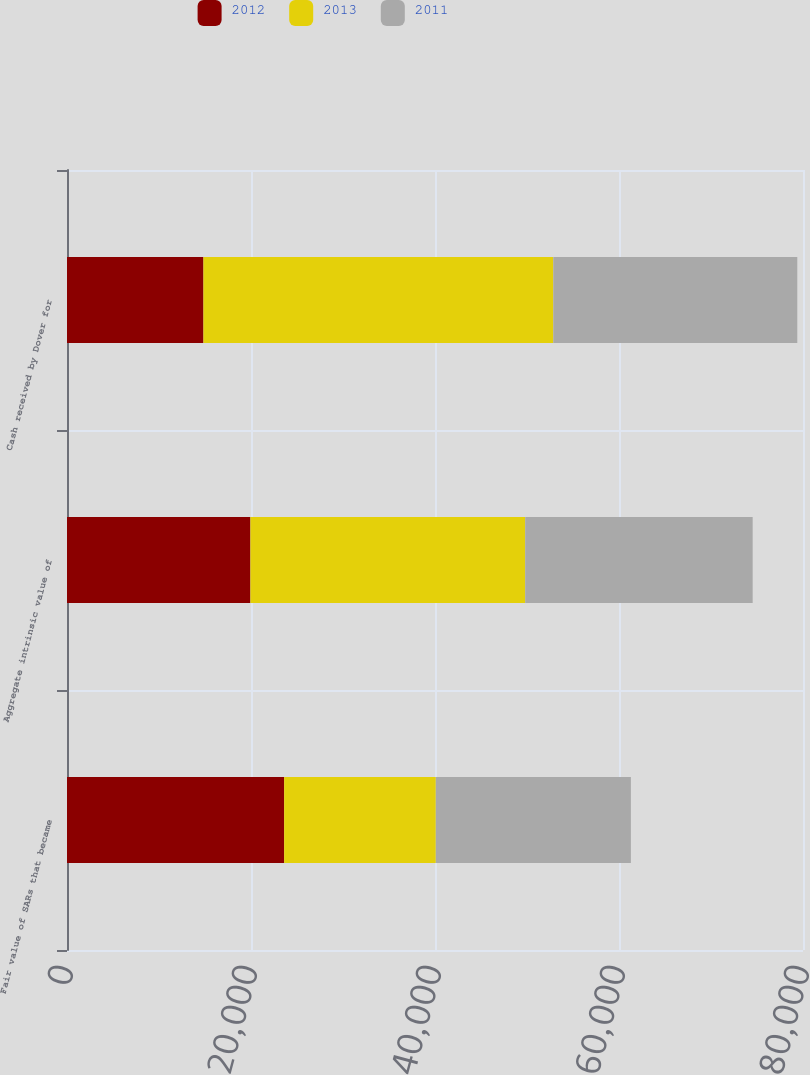Convert chart to OTSL. <chart><loc_0><loc_0><loc_500><loc_500><stacked_bar_chart><ecel><fcel>Fair value of SARs that became<fcel>Aggregate intrinsic value of<fcel>Cash received by Dover for<nl><fcel>2012<fcel>23605<fcel>19937<fcel>14830<nl><fcel>2013<fcel>16484<fcel>29866<fcel>38029<nl><fcel>2011<fcel>21202<fcel>24726<fcel>26519<nl></chart> 